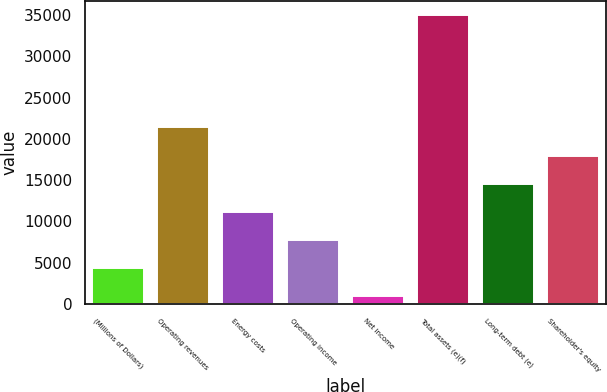<chart> <loc_0><loc_0><loc_500><loc_500><bar_chart><fcel>(Millions of Dollars)<fcel>Operating revenues<fcel>Energy costs<fcel>Operating income<fcel>Net income<fcel>Total assets (e)(f)<fcel>Long-term debt (e)<fcel>Shareholder's equity<nl><fcel>4379.6<fcel>21387.6<fcel>11182.8<fcel>7781.2<fcel>978<fcel>34994<fcel>14584.4<fcel>17986<nl></chart> 